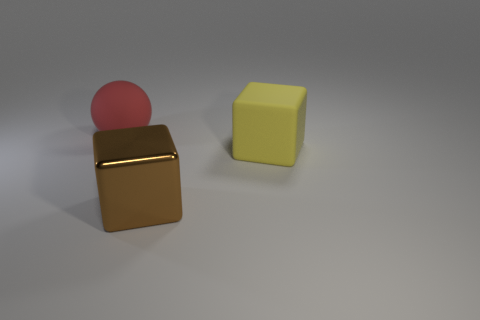Subtract all blue balls. Subtract all red cylinders. How many balls are left? 1 Add 2 big rubber spheres. How many objects exist? 5 Subtract all blocks. How many objects are left? 1 Subtract 0 red blocks. How many objects are left? 3 Subtract all large matte balls. Subtract all brown metallic cubes. How many objects are left? 1 Add 2 yellow matte objects. How many yellow matte objects are left? 3 Add 2 red matte spheres. How many red matte spheres exist? 3 